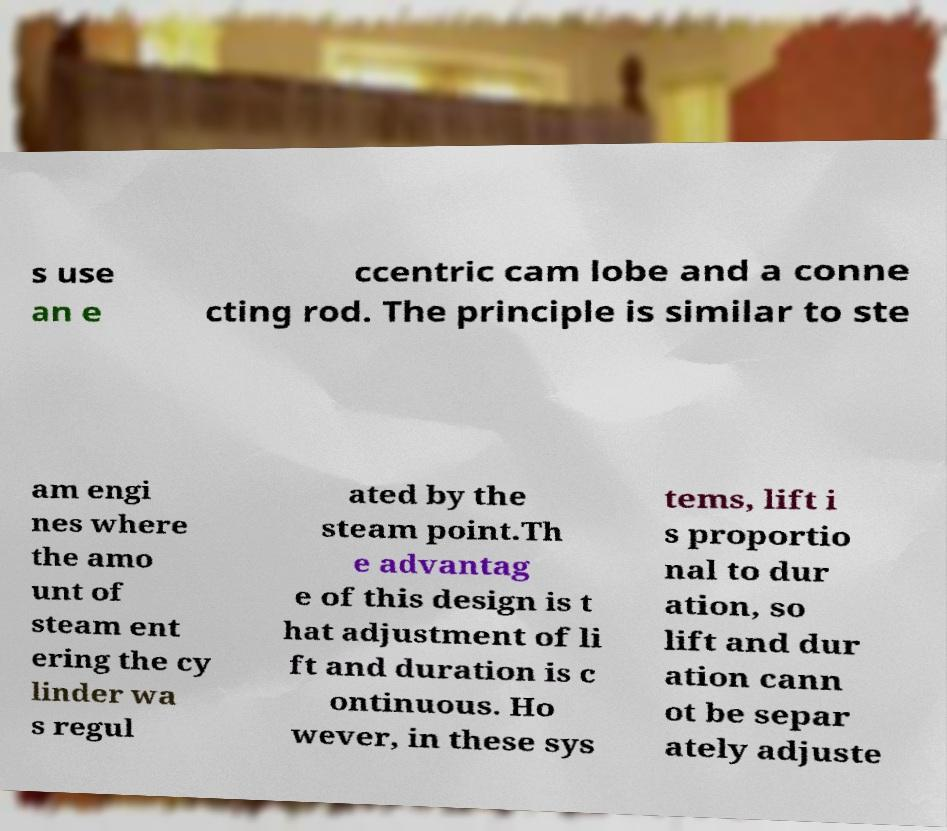Can you accurately transcribe the text from the provided image for me? s use an e ccentric cam lobe and a conne cting rod. The principle is similar to ste am engi nes where the amo unt of steam ent ering the cy linder wa s regul ated by the steam point.Th e advantag e of this design is t hat adjustment of li ft and duration is c ontinuous. Ho wever, in these sys tems, lift i s proportio nal to dur ation, so lift and dur ation cann ot be separ ately adjuste 